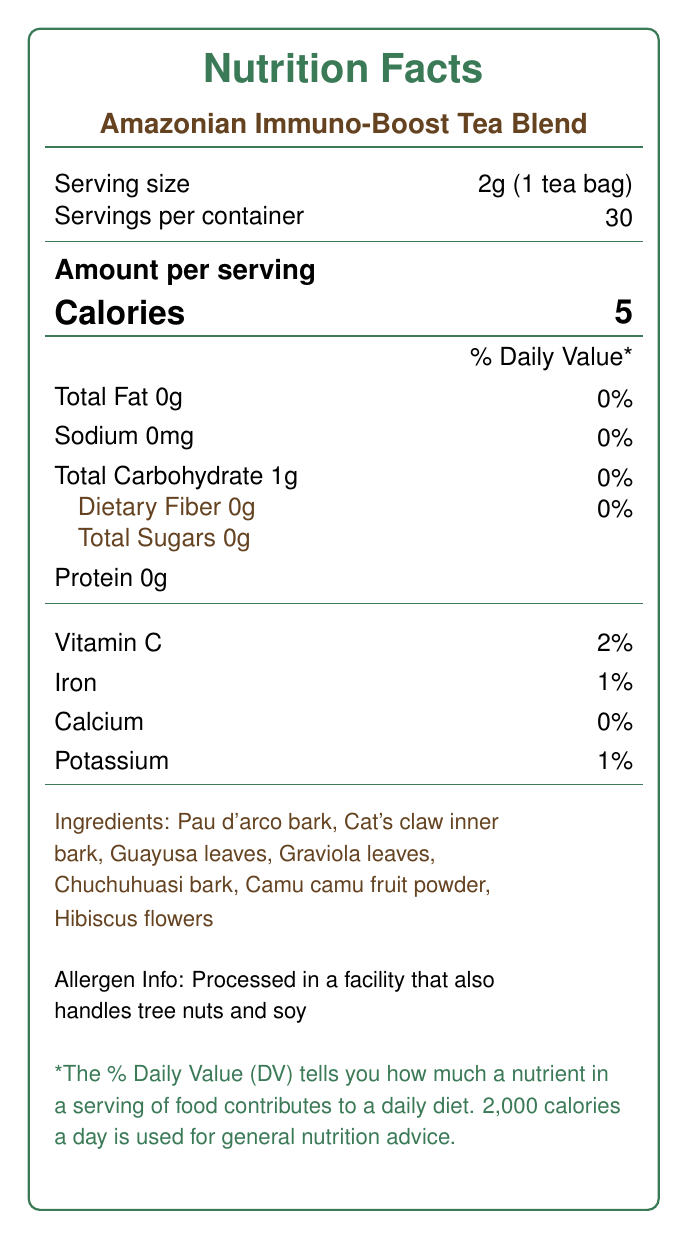what is the serving size? The document specifies that the serving size is 2g, which is equivalent to one tea bag.
Answer: 2g (1 tea bag) how many servings are in the container? The document states that there are 30 servings per container.
Answer: 30 how many calories are in one serving? The document indicates that each serving contains 5 calories.
Answer: 5 which ingredients are used in the Amazonian Immuno-Boost Tea Blend? The document lists these ingredients under the "Ingredients" section.
Answer: Pau d'arco bark, Cat's claw inner bark, Guayusa leaves, Graviola leaves, Chuchuhuasi bark, Camu camu fruit powder, Hibiscus flowers what percentage of the daily value of Vitamin C does one serving provide? Under the nutritional information, the document specifies that one serving provides 2% of the daily value for Vitamin C.
Answer: 2% what is the total carbohydrate content per serving? The nutritional information section indicates that there is 1g of total carbohydrates per serving.
Answer: 1g are there any allergens in the tea blend? The allergen information states that the tea is processed in a facility that handles tree nuts and soy.
Answer: Processed in a facility that also handles tree nuts and soy how should the tea be prepared? A. Steep in hot water for 5-7 minutes B. Boil for 10 minutes C. Microwave for 2 minutes D. Drink directly from the packet The preparation instructions indicate that the tea should be steeped in hot water (90°C/194°F) for 5-7 minutes.
Answer: A. Steep in hot water for 5-7 minutes what certifications does this product have? A. USDA Organic B. Fair Trade Certified C. Both A and B D. None of the above The document mentions that the product is both USDA Organic and Fair Trade Certified.
Answer: C. Both A and B is the tea blend naturally caffeine-free? The health claims section states that the tea blend is naturally caffeine-free.
Answer: Yes describe the main idea of the document. The document is designed to inform consumers about the nutritional content and ingredients of the tea blend, as well as providing other relevant details such as preparation instructions and certifications.
Answer: The document provides detailed nutritional information for Amazonian Immuno-Boost Tea Blend, including serving size, calories, vitamin content, ingredients, preparation instructions, and certifications. It also highlights potential health benefits and allergen information. where can the research notes for each ingredient be found? The document does not provide any specific details about where the research notes for each ingredient can be found beyond listing the ingredients themselves and their purported benefits.
Answer: Not enough information 